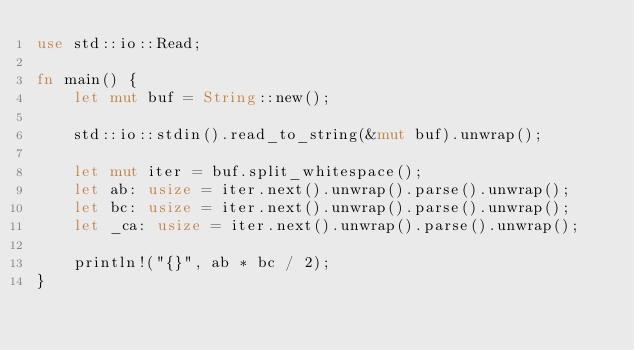Convert code to text. <code><loc_0><loc_0><loc_500><loc_500><_Rust_>use std::io::Read;

fn main() {
    let mut buf = String::new();

    std::io::stdin().read_to_string(&mut buf).unwrap();

    let mut iter = buf.split_whitespace();
    let ab: usize = iter.next().unwrap().parse().unwrap();
    let bc: usize = iter.next().unwrap().parse().unwrap();
    let _ca: usize = iter.next().unwrap().parse().unwrap();

    println!("{}", ab * bc / 2);
}
</code> 